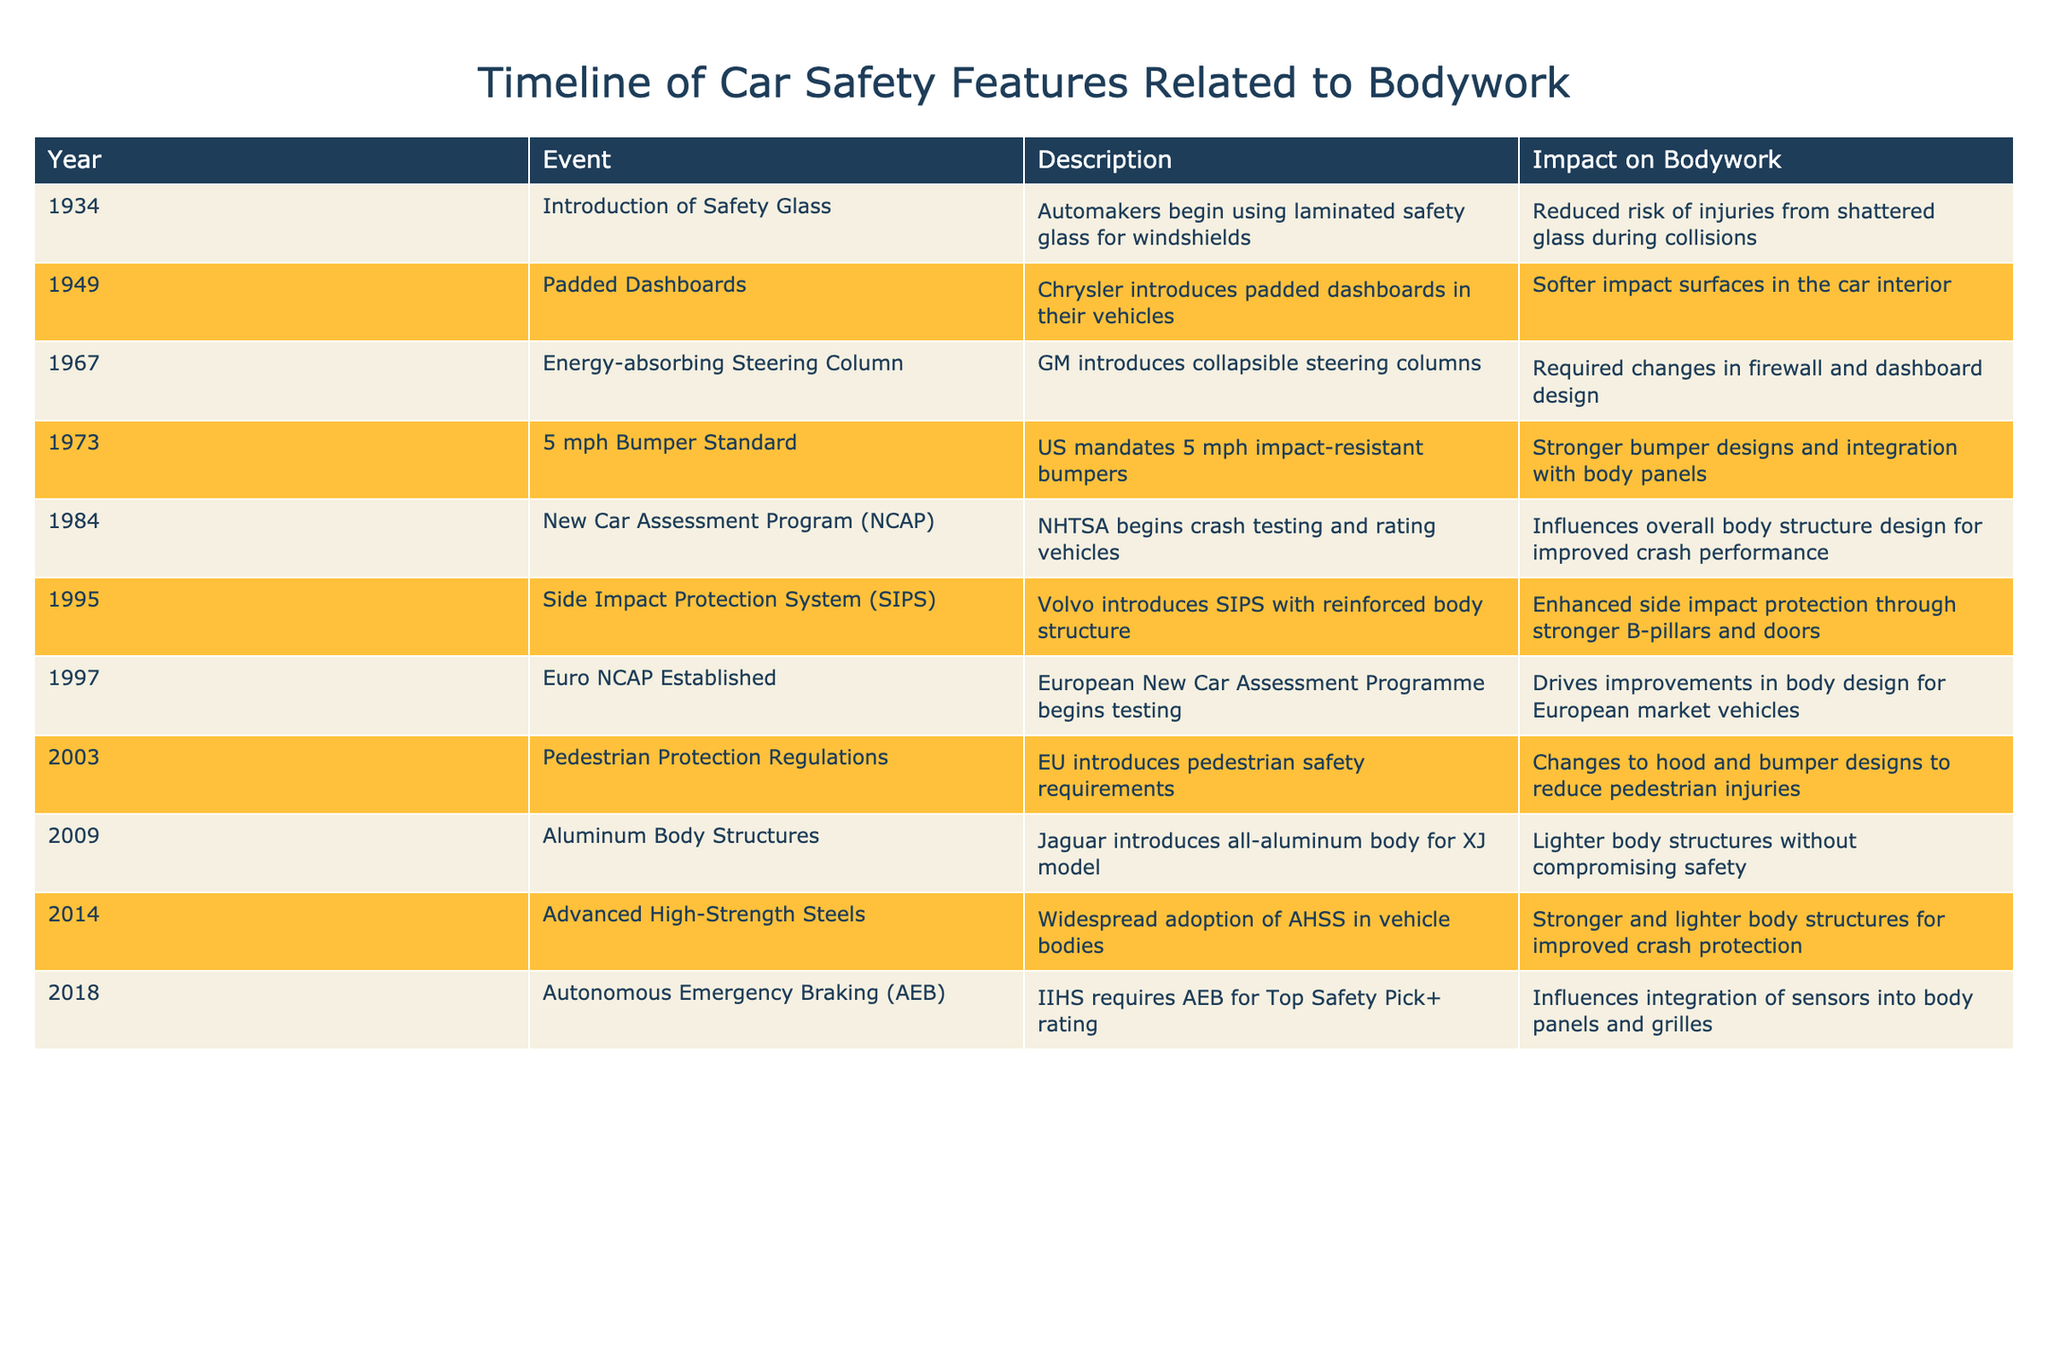What year was the 5 mph bumper standard introduced? The table indicates that the 5 mph bumper standard was introduced in 1973. We can directly locate this information in the "Year" column associated with the "5 mph Bumper Standard" event.
Answer: 1973 Which feature was introduced by Volvo in 1995? According to the table, Volvo introduced the Side Impact Protection System (SIPS) in 1995. This can be found by looking for the year 1995 in the table and matching it with the corresponding event.
Answer: Side Impact Protection System (SIPS) What is the impact of the introduction of aluminum body structures in 2009? The impact stated in the table for the introduction of aluminum body structures is that it resulted in lighter body structures without compromising safety. This information can be extracted by checking the details listed under the "Impact on Bodywork" for the year 2009.
Answer: Lighter body structures without compromising safety How many events mentioned in the table occurred before 2000? By reviewing the years listed in the table, we find that the following events occurred before 2000: 1934 (Safety Glass), 1949 (Padded Dashboards), 1967 (Energy-absorbing Steering Column), 1973 (5 mph Bumper Standard), 1984 (NCAP), 1995 (SIPS), and 1997 (Euro NCAP). Adding these, we get a total of 7 events.
Answer: 7 Is it true that all events from 1984 onwards involve improvements in safety features? Looking at the events from 1984 onward, they all focus on enhancing safety features in vehicles, such as crash testing and safety systems. Thus, it is accurate to say that these events are centered around improvements in vehicle safety. This can be verified by reviewing the descriptions of each event listed after 1984.
Answer: Yes What was the major design change required for the introduction of energy-absorbing steering columns? The table states that the introduction of energy-absorbing steering columns led to required changes in firewall and dashboard design. We find this by checking the "Description" and "Impact on Bodywork" related to the year 1967 in the table.
Answer: Changes in firewall and dashboard design What was the significance of the introduction of Advanced High-Strength Steels in 2014? The table notes that the adoption of Advanced High-Strength Steels (AHSS) allowed for stronger and lighter structures, which improve crash protection. This can be confirmed by looking at both the description and impact for the corresponding year in the table.
Answer: Stronger and lighter body structures for improved crash protection Which two features introduced in the 1990s focused on passenger protection? In the 1990s, two significant features listed are the Side Impact Protection System (SIPS) introduced by Volvo in 1995 and the Euro NCAP established in 1997. Both of these events focus on improving the safety of passengers in vehicles as highlighted in the table.
Answer: SIPS and Euro NCAP 